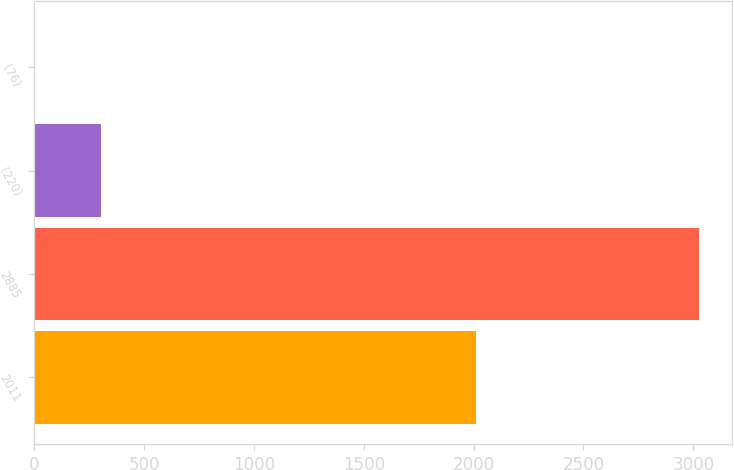<chart> <loc_0><loc_0><loc_500><loc_500><bar_chart><fcel>2011<fcel>2885<fcel>(220)<fcel>(76)<nl><fcel>2010<fcel>3027<fcel>304.5<fcel>2<nl></chart> 